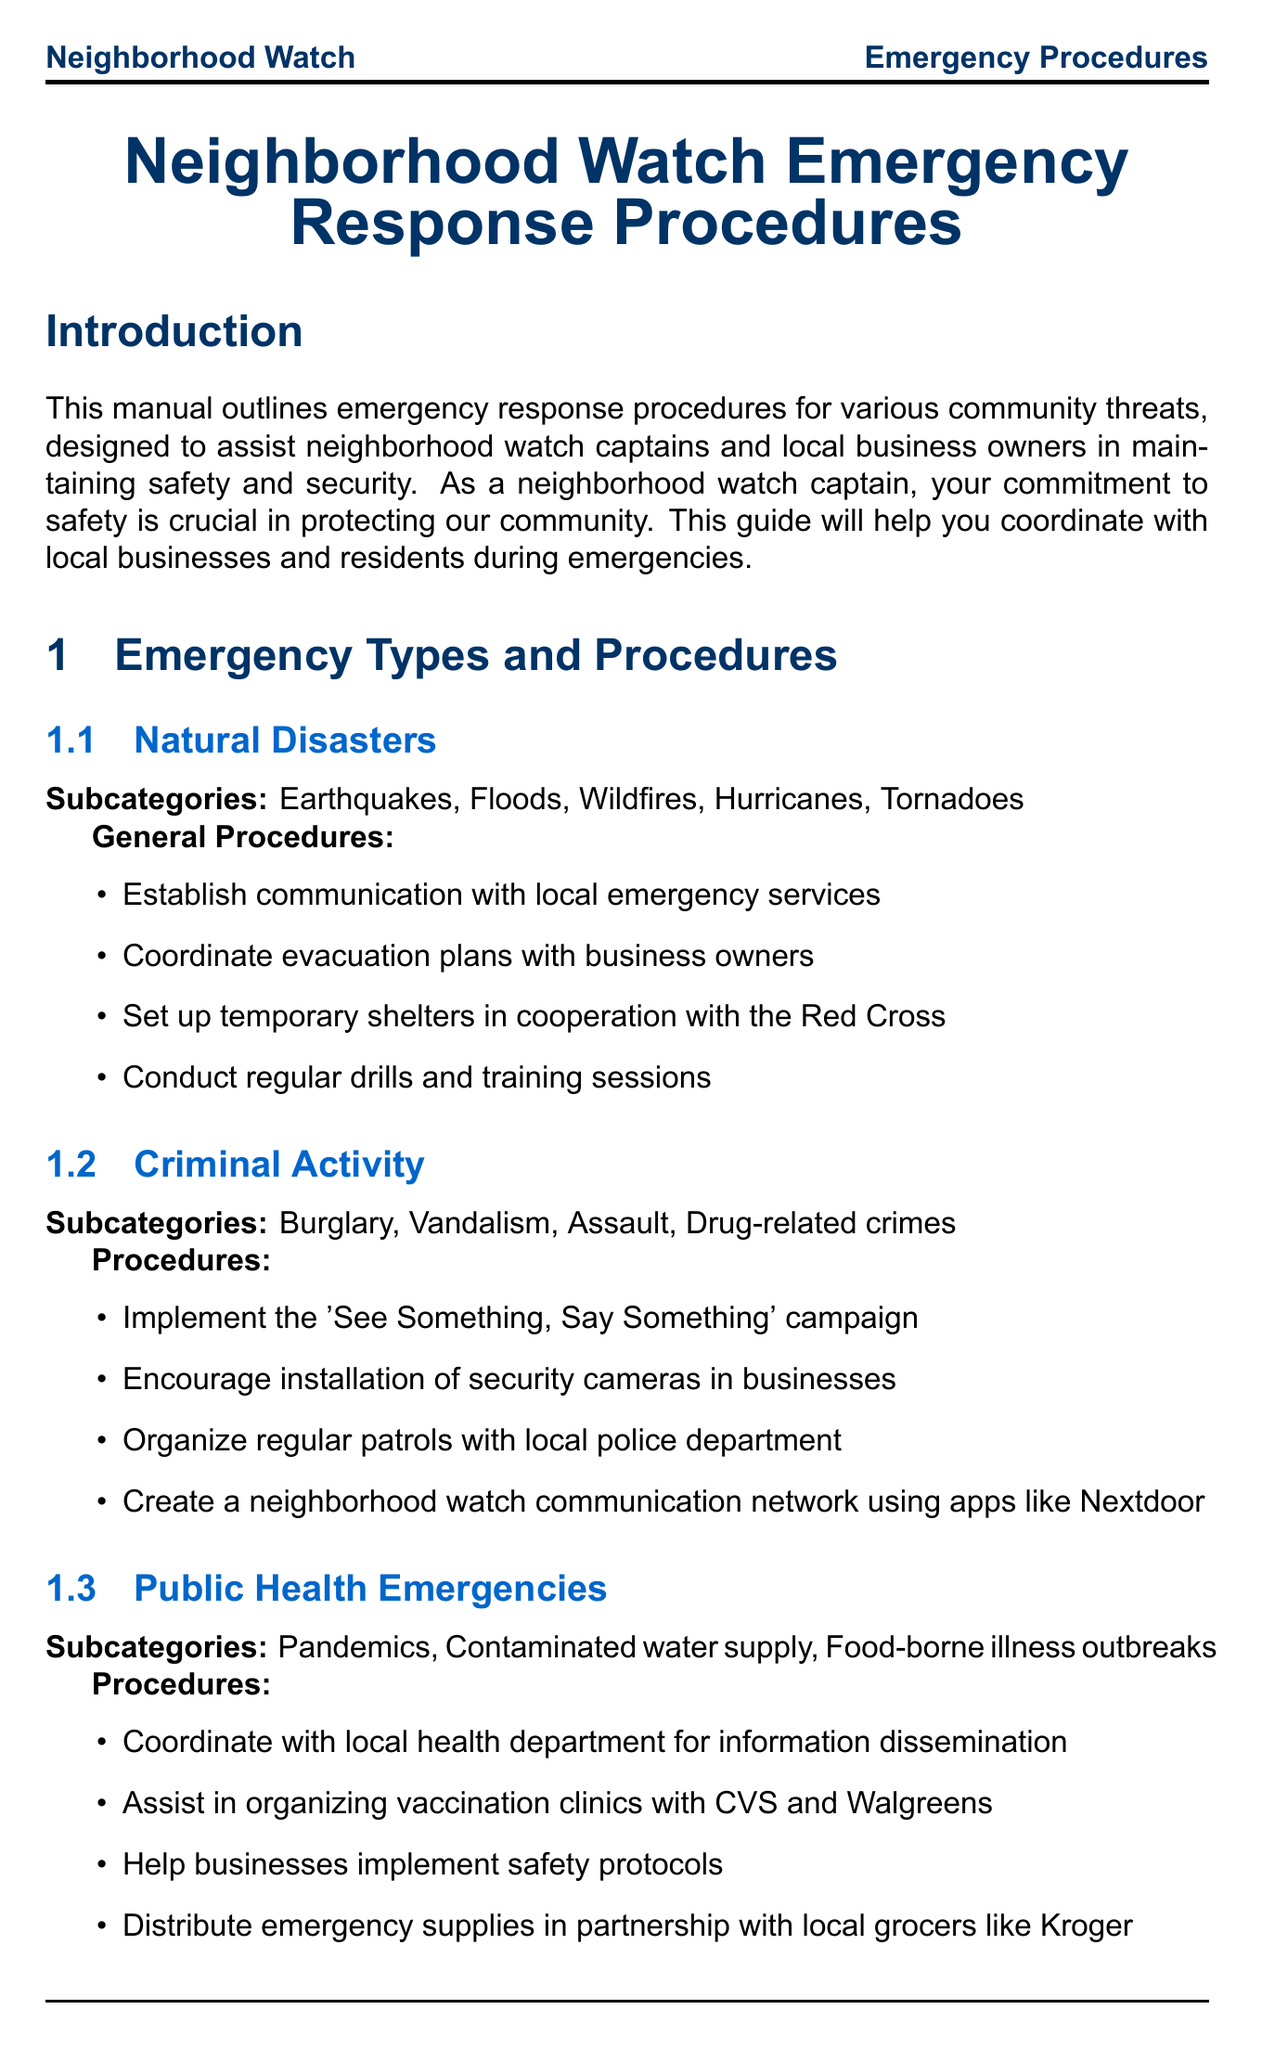What is the title of the manual? The title of the manual is located at the beginning and provides a clear indication of its content and purpose.
Answer: Neighborhood Watch Emergency Response Procedures What is the emergency contact number for Local Emergency Services? This information is found under the community resources section, providing vital contact details for emergencies.
Answer: 911 How often should training and drills be conducted? The frequency of training and drills is specifically mentioned in the training and drills section of the document.
Answer: Quarterly Which organization is mentioned for assistance in organizing vaccination clinics? This detail is included in the public health emergencies procedures, linking local businesses with health services.
Answer: CVS and Walgreens What is one responsibility of business owners outlined in the manual? Responsibilities are listed clearly under the business owner responsibilities section, emphasizing important safety tasks.
Answer: Maintain up-to-date emergency contact lists What type of emergencies does the manual address? The manual enumerates specific categories of threats to help prepare the community, listed in the emergency types section.
Answer: Natural Disasters, Criminal Activity, Public Health Emergencies, Terrorist Threats Which app is recommended for neighborhood watch communication? The recommended app is detailed in the communication protocols section, promoting effective communication among members.
Answer: SafeSpringfield What is one key takeaway mentioned in the conclusion? The key takeaways are summarized at the end, offering insights into effective emergency response strategies.
Answer: Preparedness is key to effective emergency response 